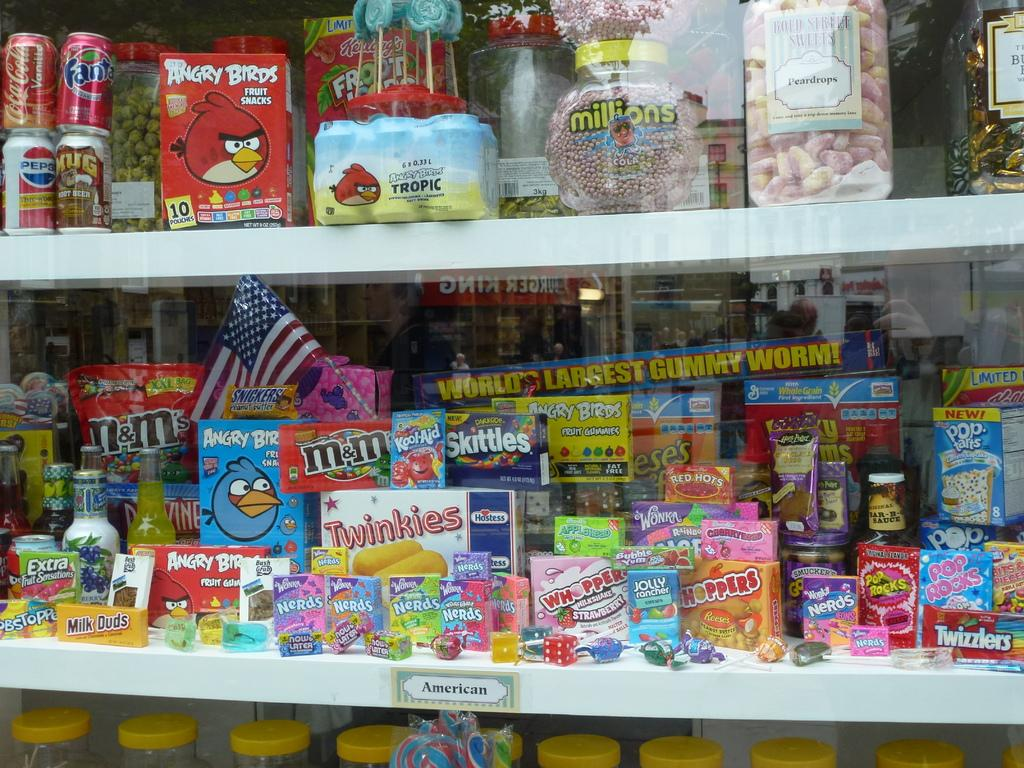<image>
Give a short and clear explanation of the subsequent image. closet shelves packed full with junk food including twinkies and m&ms on the bottom shelf 